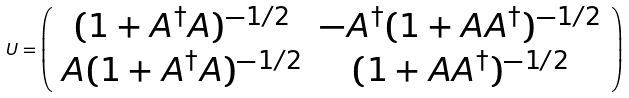<formula> <loc_0><loc_0><loc_500><loc_500>U = \left ( \begin{array} { c c } ( 1 + A ^ { \dagger } A ) ^ { - 1 / 2 } & - A ^ { \dagger } ( 1 + A A ^ { \dagger } ) ^ { - 1 / 2 } \\ A ( 1 + A ^ { \dagger } A ) ^ { - 1 / 2 } & ( 1 + A A ^ { \dagger } ) ^ { - 1 / 2 } \end{array} \right )</formula> 